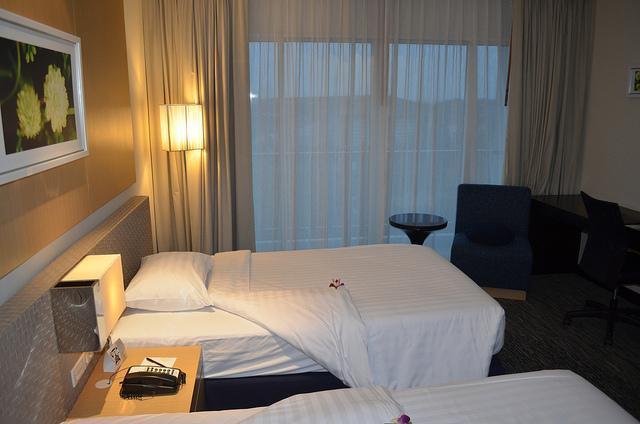How many pillows are there?
Give a very brief answer. 1. How many lamps are there?
Give a very brief answer. 1. How many windows are open?
Give a very brief answer. 0. How many chairs are there?
Give a very brief answer. 2. How many beds are there?
Give a very brief answer. 2. How many of the surfboards are yellow?
Give a very brief answer. 0. 